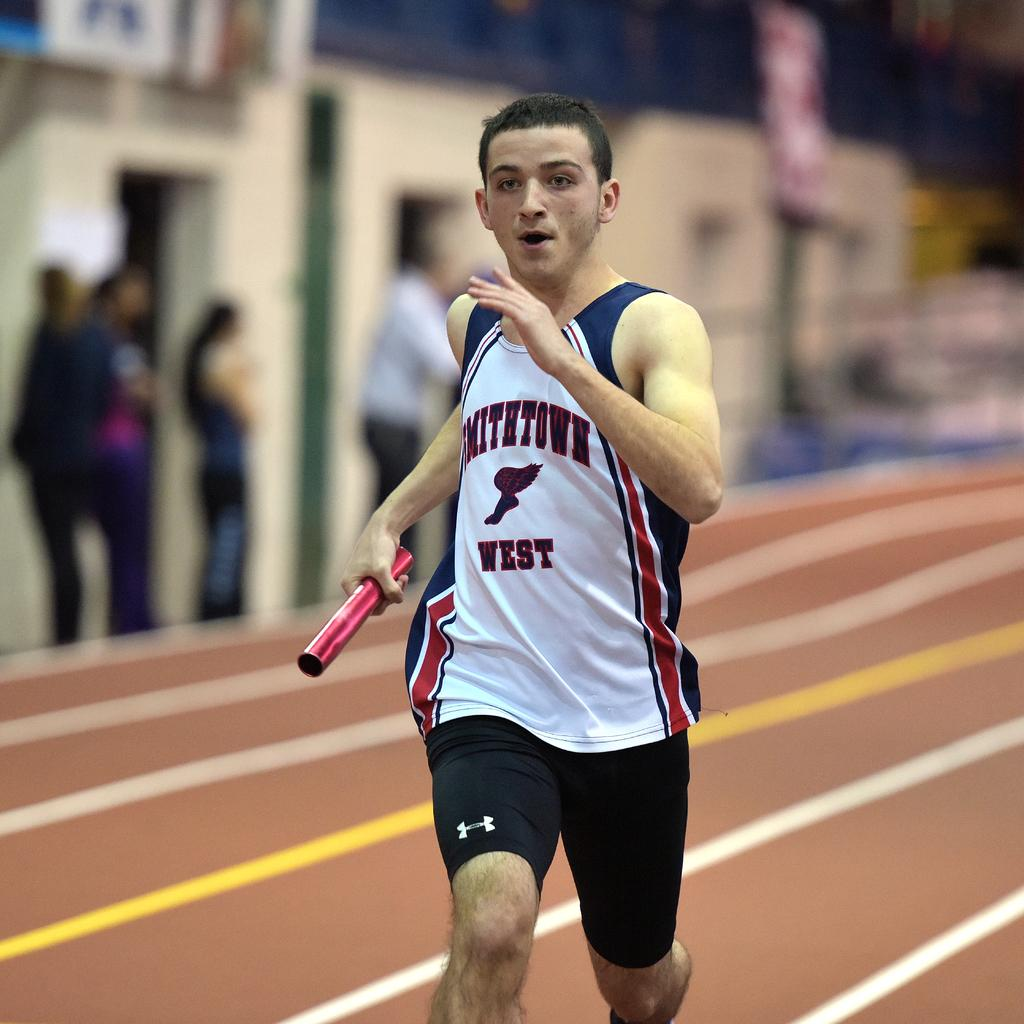<image>
Provide a brief description of the given image. Smithtown west running team is racing on a track field with a baton 